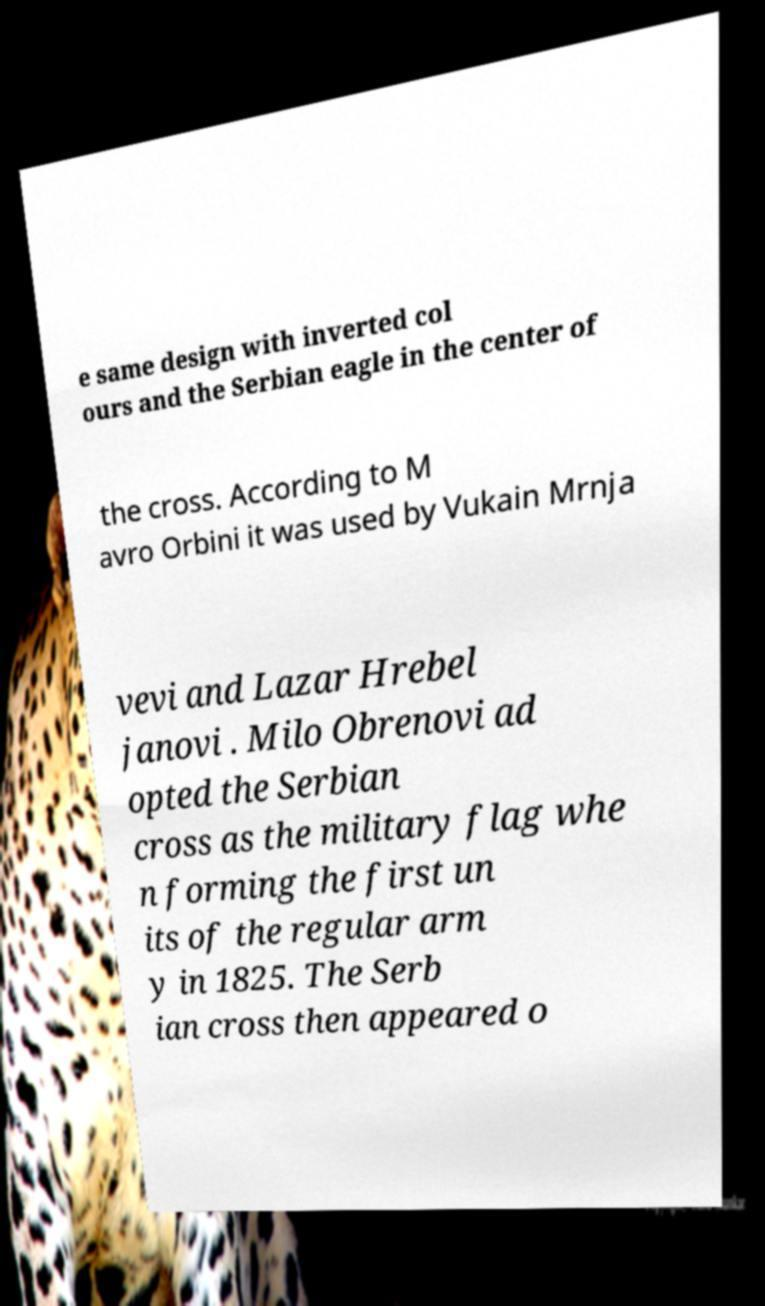For documentation purposes, I need the text within this image transcribed. Could you provide that? e same design with inverted col ours and the Serbian eagle in the center of the cross. According to M avro Orbini it was used by Vukain Mrnja vevi and Lazar Hrebel janovi . Milo Obrenovi ad opted the Serbian cross as the military flag whe n forming the first un its of the regular arm y in 1825. The Serb ian cross then appeared o 